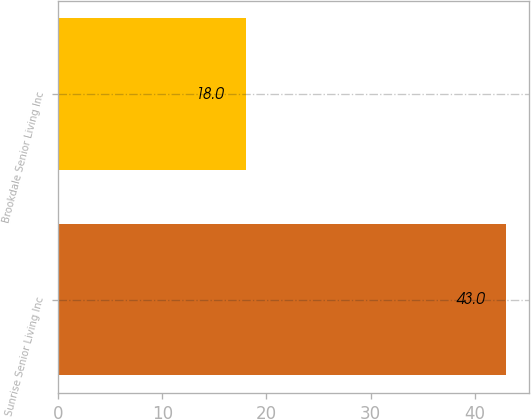Convert chart. <chart><loc_0><loc_0><loc_500><loc_500><bar_chart><fcel>Sunrise Senior Living Inc<fcel>Brookdale Senior Living Inc<nl><fcel>43<fcel>18<nl></chart> 